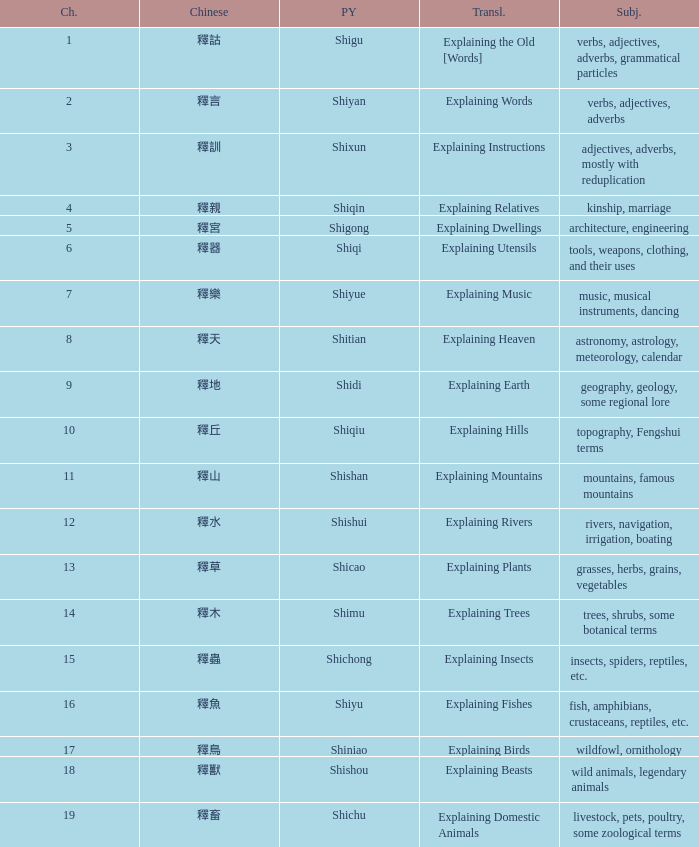Name the total number of chapter for chinese of 釋宮 1.0. 